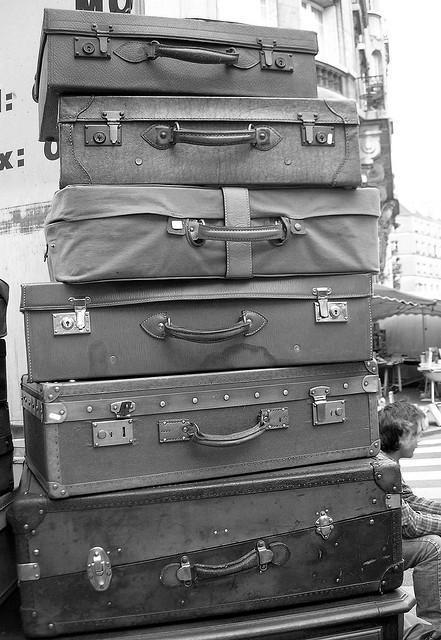How many suitcases are shown?
Give a very brief answer. 6. How many people are visible in the picture?
Give a very brief answer. 1. How many suitcases are on top of each other?
Give a very brief answer. 6. How many brown suitcases are there?
Give a very brief answer. 6. How many suitcases are in the photo?
Give a very brief answer. 6. How many keyboards can be seen?
Give a very brief answer. 0. 